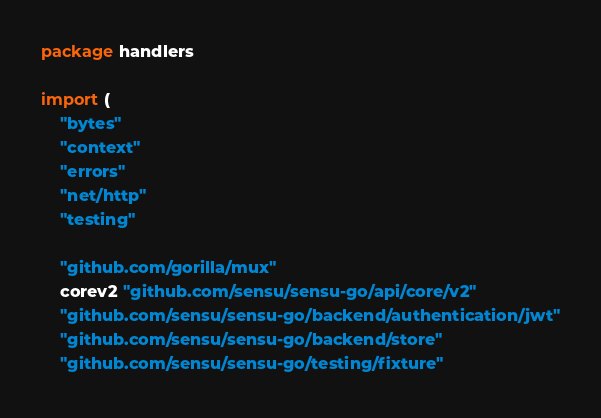Convert code to text. <code><loc_0><loc_0><loc_500><loc_500><_Go_>package handlers

import (
	"bytes"
	"context"
	"errors"
	"net/http"
	"testing"

	"github.com/gorilla/mux"
	corev2 "github.com/sensu/sensu-go/api/core/v2"
	"github.com/sensu/sensu-go/backend/authentication/jwt"
	"github.com/sensu/sensu-go/backend/store"
	"github.com/sensu/sensu-go/testing/fixture"</code> 